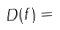<formula> <loc_0><loc_0><loc_500><loc_500>D ( f ) =</formula> 